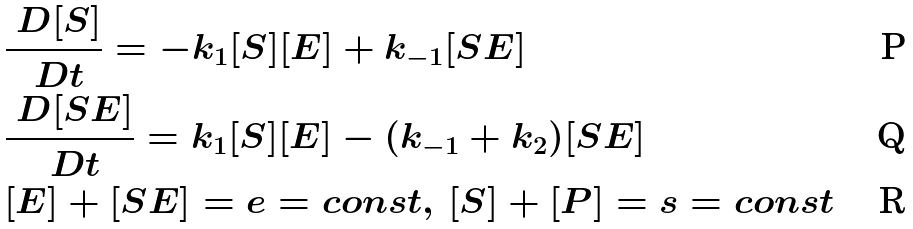Convert formula to latex. <formula><loc_0><loc_0><loc_500><loc_500>& \frac { \ D [ S ] } { \ D t } = - k _ { 1 } [ S ] [ E ] + k _ { - 1 } [ S E ] \, \\ & \frac { \ D [ S E ] } { \ D t } = k _ { 1 } [ S ] [ E ] - ( k _ { - 1 } + k _ { 2 } ) [ S E ] \, \\ & [ E ] + [ S E ] = e = c o n s t , \, [ S ] + [ P ] = s = c o n s t \,</formula> 